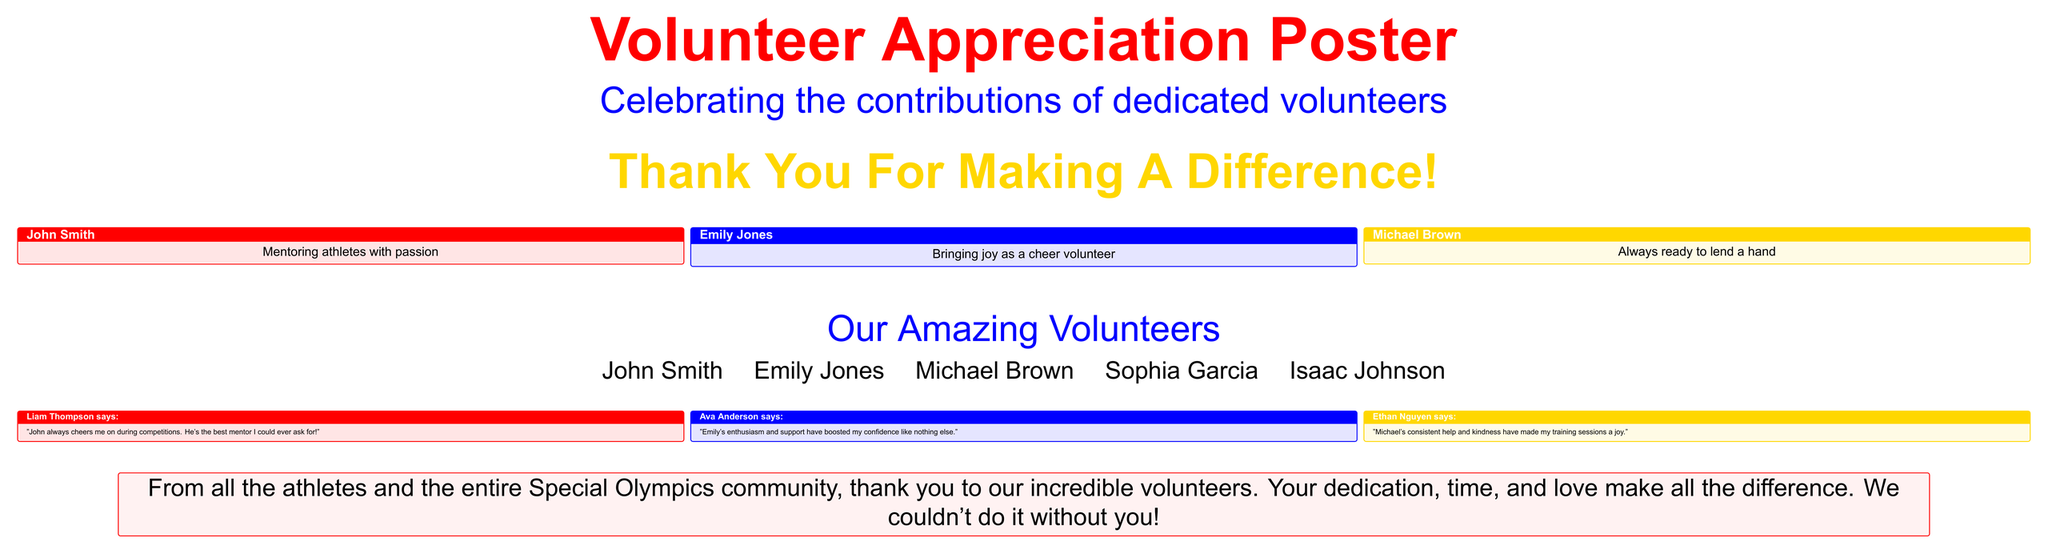What is the title of the poster? The title is prominently displayed at the top of the poster, which is "Volunteer Appreciation Poster."
Answer: Volunteer Appreciation Poster Who is one of the volunteers recognized in the poster? The poster lists several volunteers, including John Smith, Emily Jones, and Michael Brown.
Answer: John Smith What color is used for the title text? The title text is colored in a specific shade, which is identified as "specialred."
Answer: specialred How many testimonials are included in the poster? There are a total of three testimonials provided by different athletes about the volunteers.
Answer: 3 What does Liam Thompson say about John? Liam's quote expresses his appreciation for John's support during competitions.
Answer: "John always cheers me on during competitions. He's the best mentor I could ever ask for!" What is the primary message of the poster? The poster conveys a heartfelt message of gratitude towards the volunteers for their contributions to the community.
Answer: Thank you to our incredible volunteers Which athlete mentions Emily? The testimonial provided by Ava Anderson mentions Emily's positive impact.
Answer: Ava Anderson What is Michael Brown thanked for? The testimonial highlights Michael's consistent help and kindness during training sessions.
Answer: "Michael's consistent help and kindness have made my training sessions a joy." 